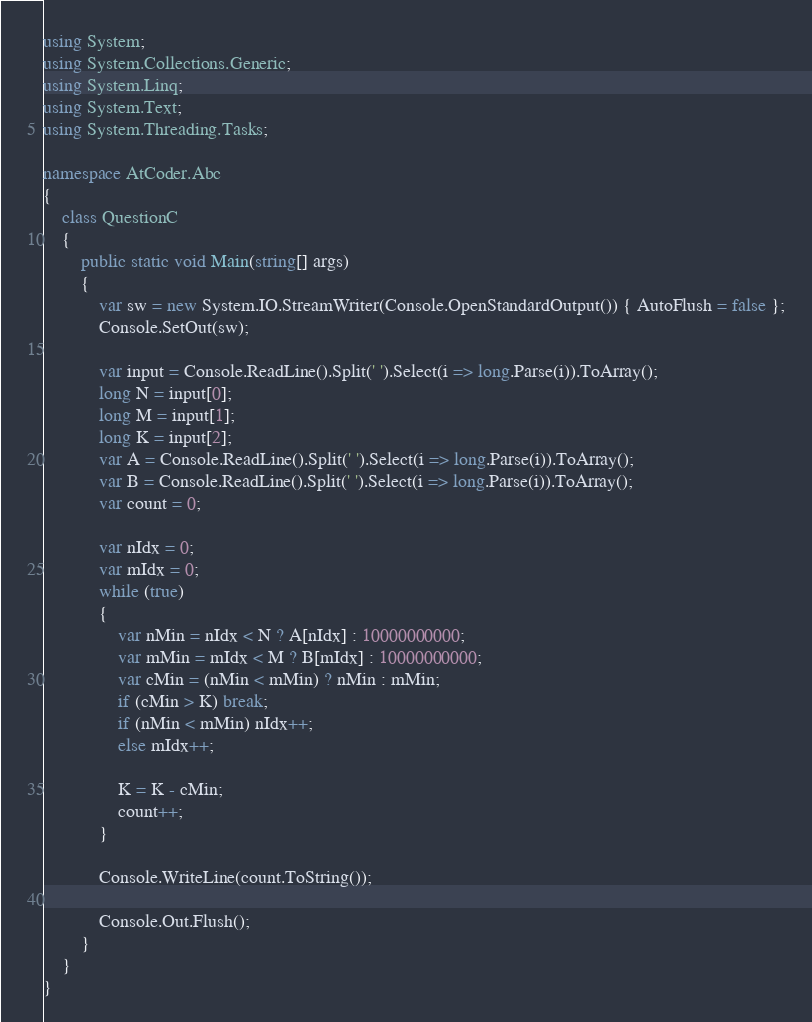Convert code to text. <code><loc_0><loc_0><loc_500><loc_500><_C#_>using System;
using System.Collections.Generic;
using System.Linq;
using System.Text;
using System.Threading.Tasks;

namespace AtCoder.Abc
{
    class QuestionC
    {
        public static void Main(string[] args)
        {
            var sw = new System.IO.StreamWriter(Console.OpenStandardOutput()) { AutoFlush = false };
            Console.SetOut(sw);

            var input = Console.ReadLine().Split(' ').Select(i => long.Parse(i)).ToArray();
            long N = input[0];
            long M = input[1];
            long K = input[2];
            var A = Console.ReadLine().Split(' ').Select(i => long.Parse(i)).ToArray();
            var B = Console.ReadLine().Split(' ').Select(i => long.Parse(i)).ToArray();
            var count = 0;

            var nIdx = 0;
            var mIdx = 0;
            while (true)
            {
                var nMin = nIdx < N ? A[nIdx] : 10000000000;
                var mMin = mIdx < M ? B[mIdx] : 10000000000;
                var cMin = (nMin < mMin) ? nMin : mMin;
                if (cMin > K) break;
                if (nMin < mMin) nIdx++;
                else mIdx++;

                K = K - cMin;
                count++;
            }

            Console.WriteLine(count.ToString());

            Console.Out.Flush();
        }
    }
}
</code> 